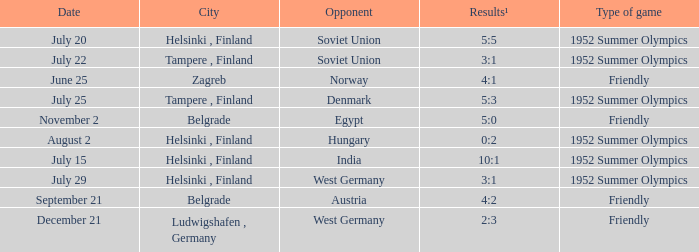What are the outcomes of the friendly match that took place on june 25? 4:1. 